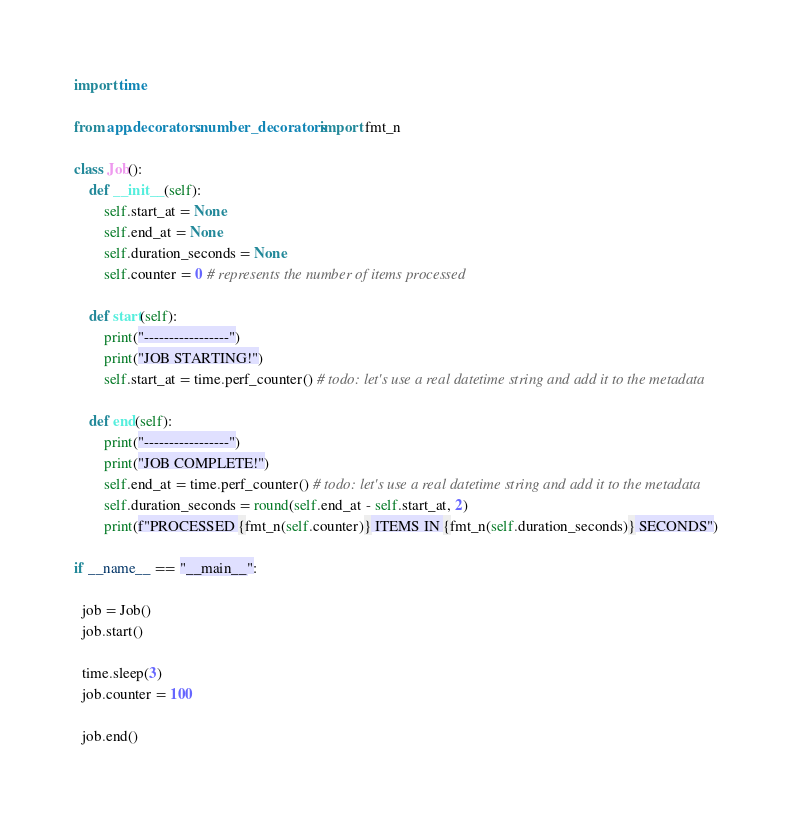Convert code to text. <code><loc_0><loc_0><loc_500><loc_500><_Python_>
import time

from app.decorators.number_decorators import fmt_n

class Job():
    def __init__(self):
        self.start_at = None
        self.end_at = None
        self.duration_seconds = None
        self.counter = 0 # represents the number of items processed

    def start(self):
        print("-----------------")
        print("JOB STARTING!")
        self.start_at = time.perf_counter() # todo: let's use a real datetime string and add it to the metadata

    def end(self):
        print("-----------------")
        print("JOB COMPLETE!")
        self.end_at = time.perf_counter() # todo: let's use a real datetime string and add it to the metadata
        self.duration_seconds = round(self.end_at - self.start_at, 2)
        print(f"PROCESSED {fmt_n(self.counter)} ITEMS IN {fmt_n(self.duration_seconds)} SECONDS")

if __name__ == "__main__":

  job = Job()
  job.start()

  time.sleep(3)
  job.counter = 100

  job.end()
</code> 